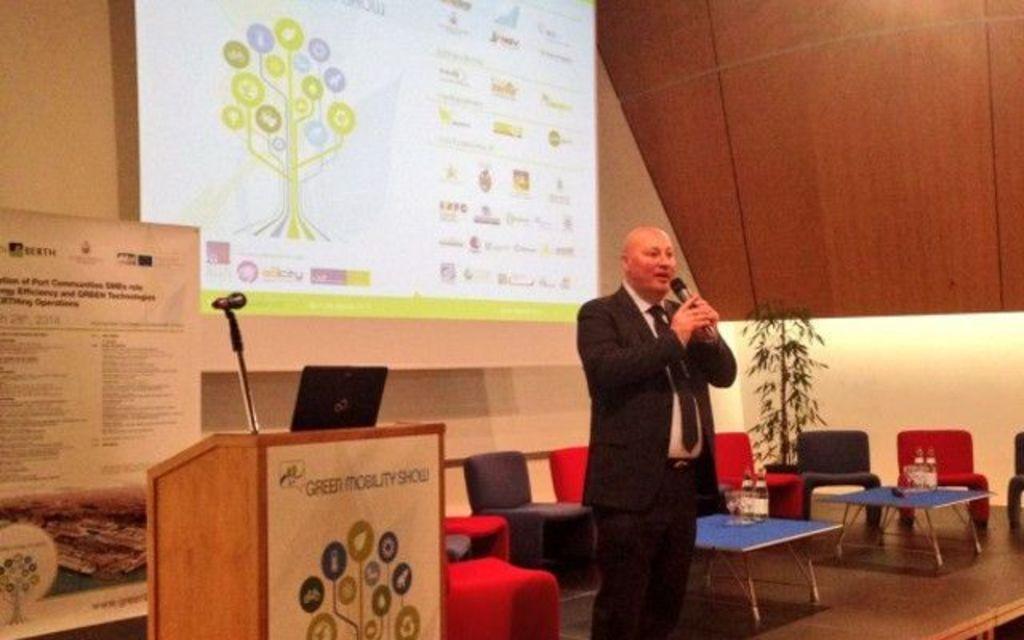Please provide a concise description of this image. The person wearing suit is standing and speaking in front of a mic and there are chairs and tables and a projected image behind him. 